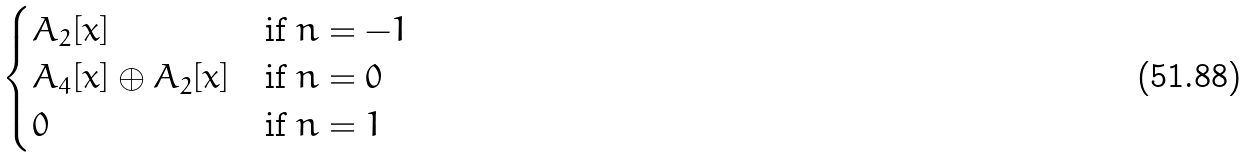Convert formula to latex. <formula><loc_0><loc_0><loc_500><loc_500>\begin{cases} A _ { 2 } [ x ] & \text {if $n=-1$} \\ A _ { 4 } [ x ] \oplus A _ { 2 } [ x ] & \text {if $n=0$} \\ 0 & \text {if $n=1$} \end{cases}</formula> 